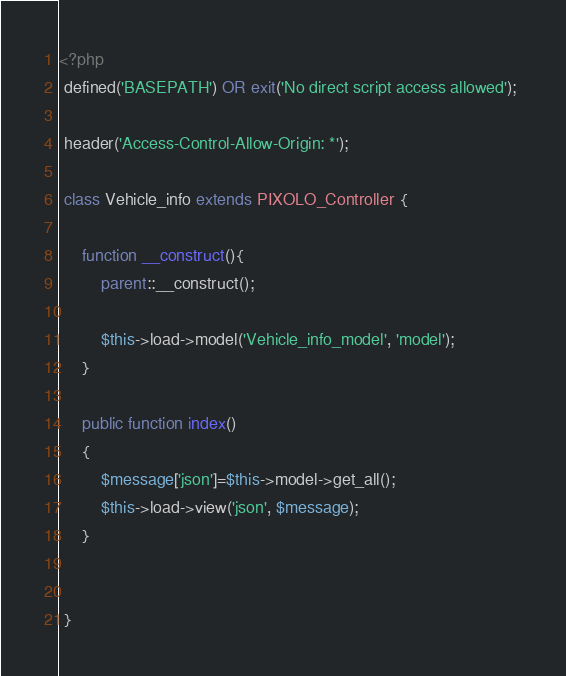Convert code to text. <code><loc_0><loc_0><loc_500><loc_500><_PHP_><?php 
 defined('BASEPATH') OR exit('No direct script access allowed'); 
 
 header('Access-Control-Allow-Origin: *'); 
 
 class Vehicle_info extends PIXOLO_Controller { 
 
 	 function __construct(){ 
 	 	 parent::__construct(); 
 
 	 	 $this->load->model('Vehicle_info_model', 'model'); 
 	 } 

 	 public function index() 
 	 { 
 	 	 $message['json']=$this->model->get_all(); 
 	 	 $this->load->view('json', $message); 
 	 } 

 	 
 }</code> 